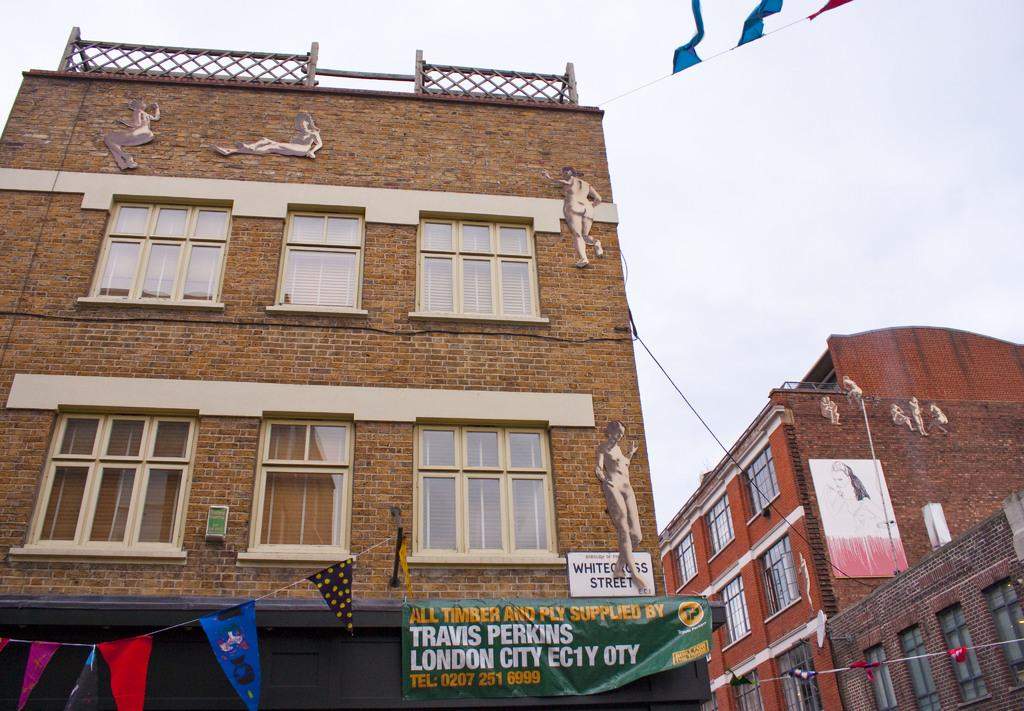What type of structures can be seen in the image? There are buildings in the image. What decorative elements are present in the image? There are banners in the image. What architectural features can be observed on the buildings? There are windows in the image. What other objects can be seen in the image besides buildings and banners? There are other objects in the image. What can be seen in the background of the image? The sky is visible in the background of the image. Can you see a chain attached to the buildings in the image? There is no chain attached to the buildings in the image. Are there any rats visible in the image? There are no rats present in the image. 